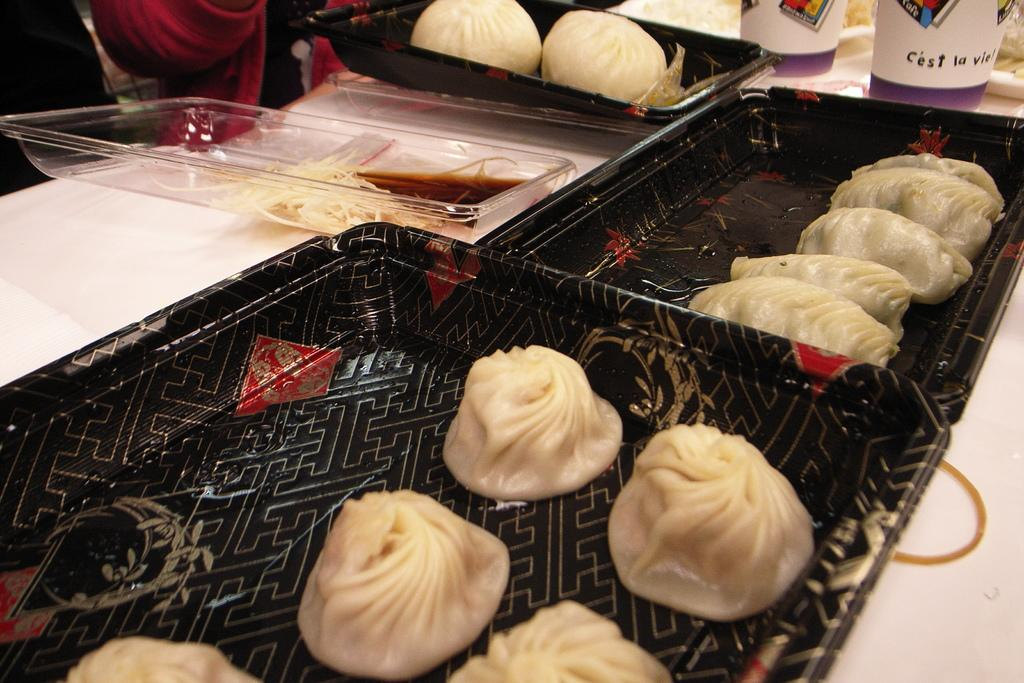What type of trays are the food items placed on in the image? The food items are placed on black trays in the image. What color is the surface where the cups are placed? The cups are placed on a white surface in the image. How many quinces are on the black trays in the image? There is no mention of quinces in the image, so it is impossible to determine their presence or quantity. 